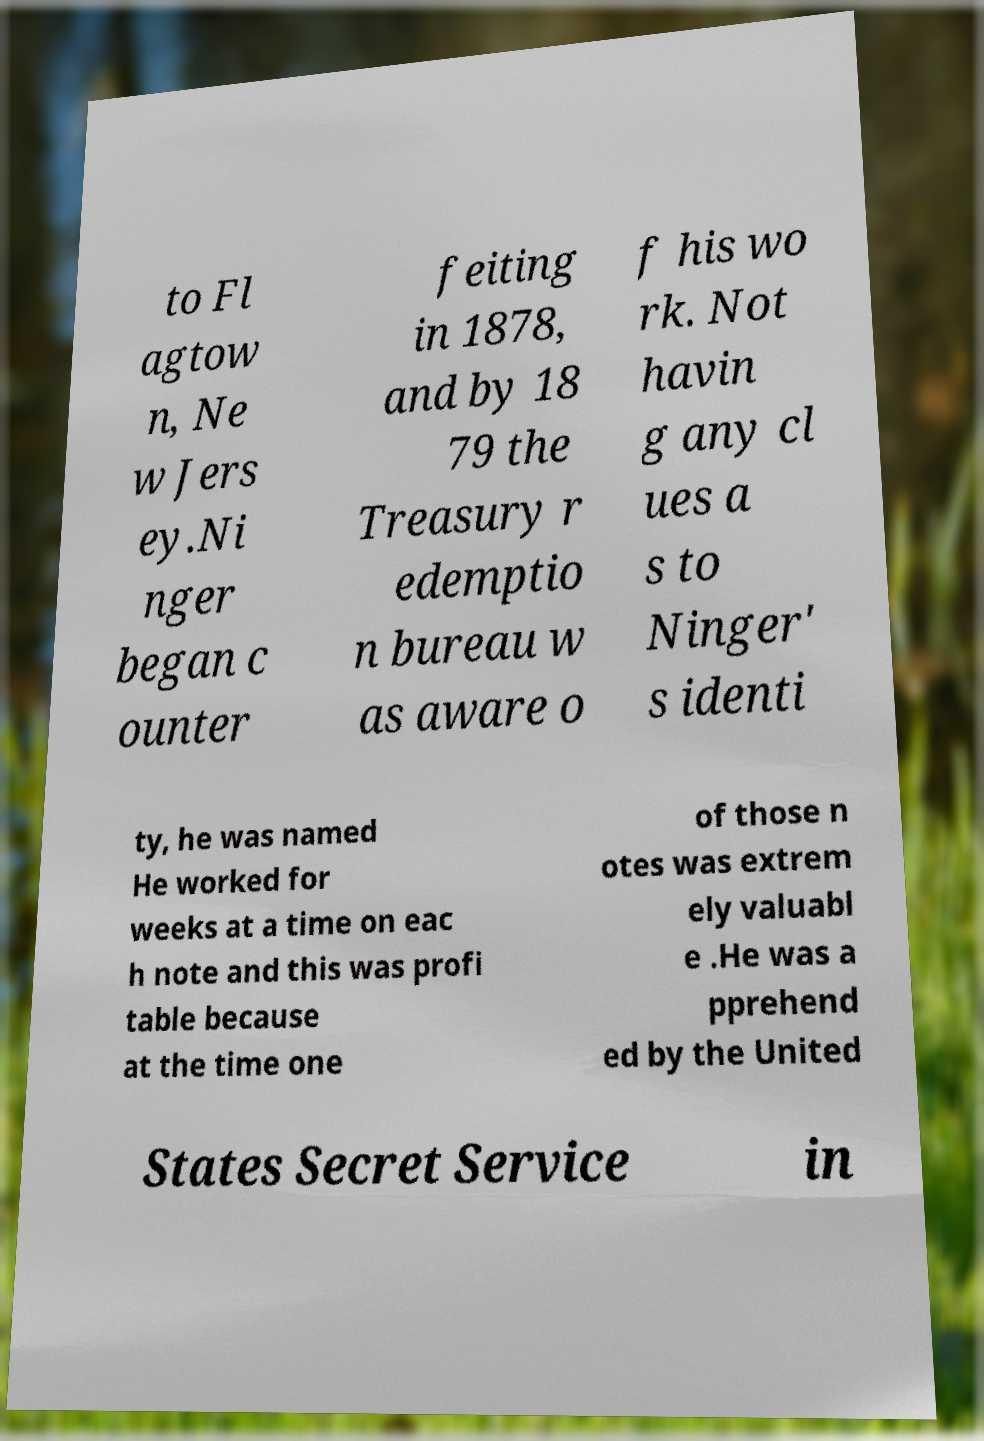There's text embedded in this image that I need extracted. Can you transcribe it verbatim? to Fl agtow n, Ne w Jers ey.Ni nger began c ounter feiting in 1878, and by 18 79 the Treasury r edemptio n bureau w as aware o f his wo rk. Not havin g any cl ues a s to Ninger' s identi ty, he was named He worked for weeks at a time on eac h note and this was profi table because at the time one of those n otes was extrem ely valuabl e .He was a pprehend ed by the United States Secret Service in 